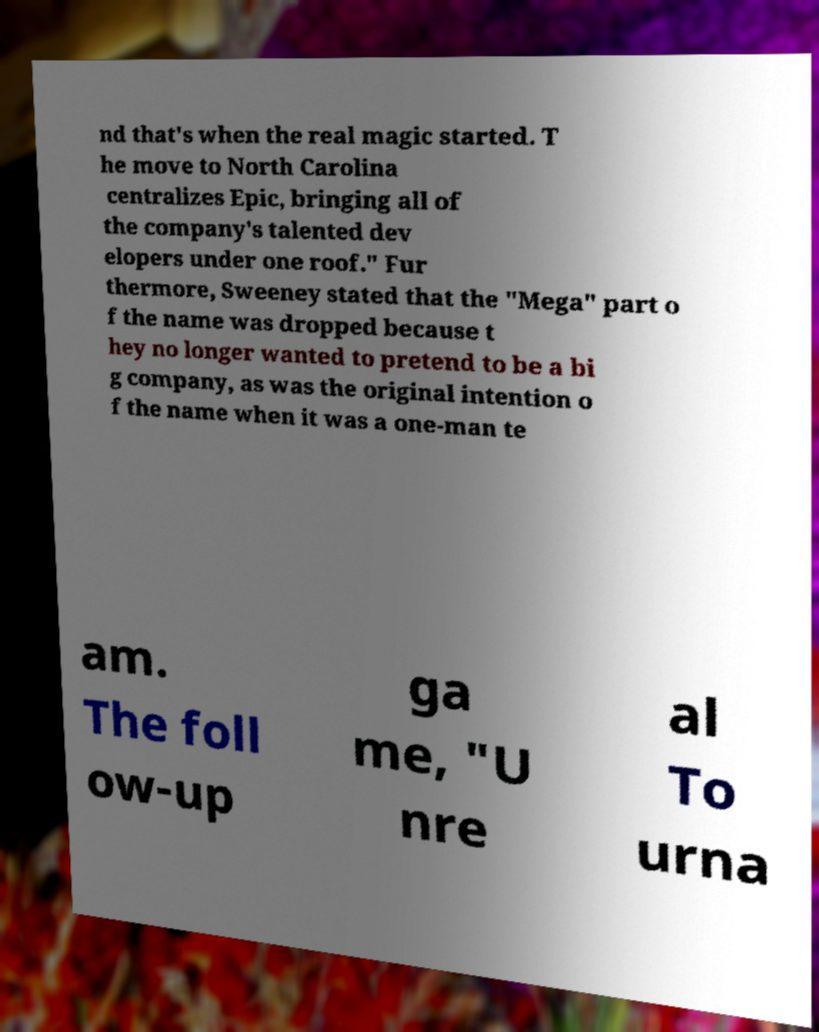Could you assist in decoding the text presented in this image and type it out clearly? nd that's when the real magic started. T he move to North Carolina centralizes Epic, bringing all of the company's talented dev elopers under one roof." Fur thermore, Sweeney stated that the "Mega" part o f the name was dropped because t hey no longer wanted to pretend to be a bi g company, as was the original intention o f the name when it was a one-man te am. The foll ow-up ga me, "U nre al To urna 